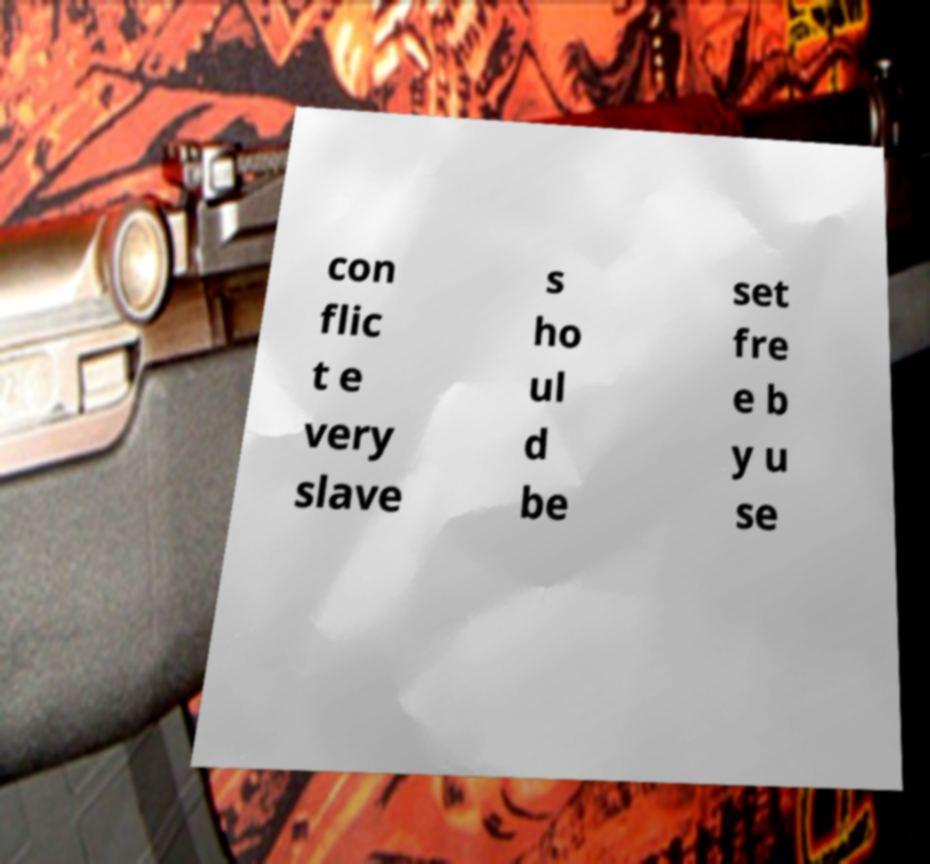Can you accurately transcribe the text from the provided image for me? con flic t e very slave s ho ul d be set fre e b y u se 